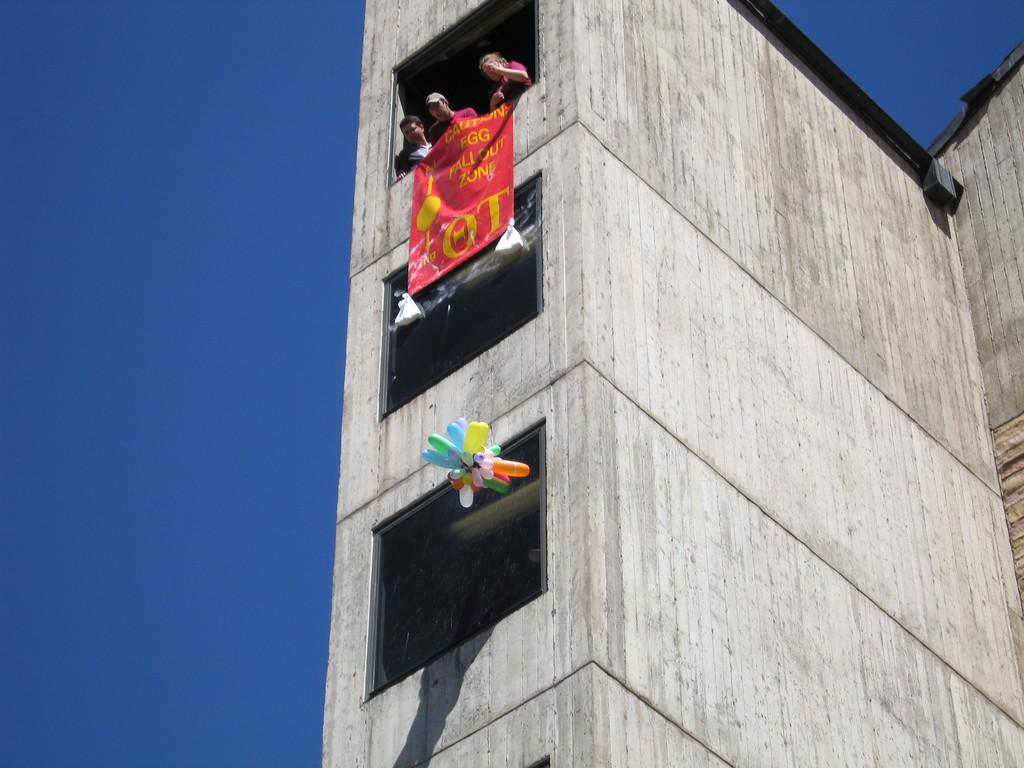What structure is depicted in the image? There is a building in the image. What are the people on the building doing? People are standing on the top floor of the building. What decorative item can be seen in the image? There is a banner in the image. What additional objects are present at the bottom of the image? Balloons are present at the bottom of the image. What can be seen in the background of the image? The sky is visible in the background of the image. Where is the person playing the horn in the image? There is no person playing a horn in the image. What type of stage is set up for the performance in the image? There is no stage or performance present in the image. 